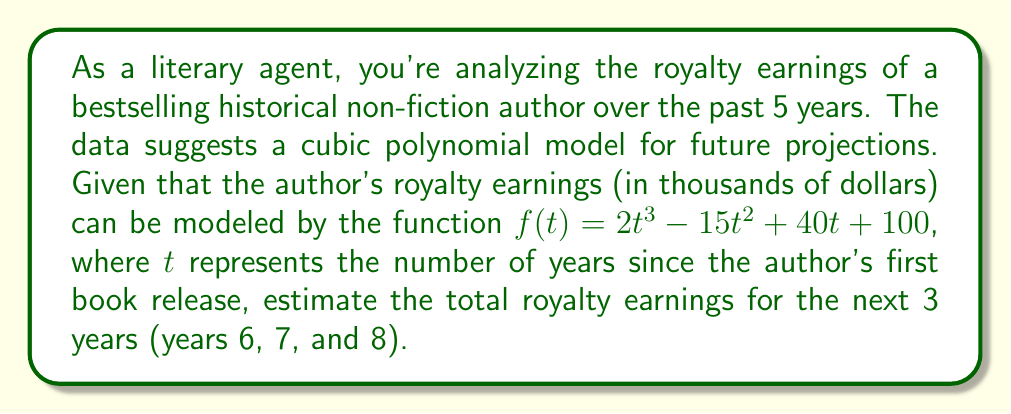Provide a solution to this math problem. To solve this problem, we need to follow these steps:

1) The given function is $f(t) = 2t^3 - 15t^2 + 40t + 100$, where $f(t)$ represents the royalty earnings in thousands of dollars for year $t$.

2) We need to calculate the earnings for years 6, 7, and 8:

   For year 6:
   $f(6) = 2(6^3) - 15(6^2) + 40(6) + 100$
   $= 2(216) - 15(36) + 240 + 100$
   $= 432 - 540 + 240 + 100$
   $= 232$ thousand dollars

   For year 7:
   $f(7) = 2(7^3) - 15(7^2) + 40(7) + 100$
   $= 2(343) - 15(49) + 280 + 100$
   $= 686 - 735 + 280 + 100$
   $= 331$ thousand dollars

   For year 8:
   $f(8) = 2(8^3) - 15(8^2) + 40(8) + 100$
   $= 2(512) - 15(64) + 320 + 100$
   $= 1024 - 960 + 320 + 100$
   $= 484$ thousand dollars

3) To get the total earnings for these three years, we sum these values:

   Total = $232 + 331 + 484 = 1047$ thousand dollars

4) Converting to millions: $1047$ thousand dollars = $1.047$ million dollars
Answer: $1.047$ million dollars 